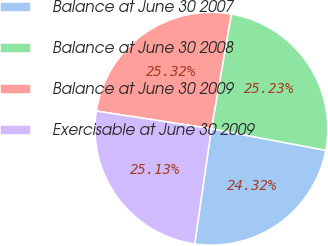Convert chart. <chart><loc_0><loc_0><loc_500><loc_500><pie_chart><fcel>Balance at June 30 2007<fcel>Balance at June 30 2008<fcel>Balance at June 30 2009<fcel>Exercisable at June 30 2009<nl><fcel>24.32%<fcel>25.23%<fcel>25.32%<fcel>25.13%<nl></chart> 